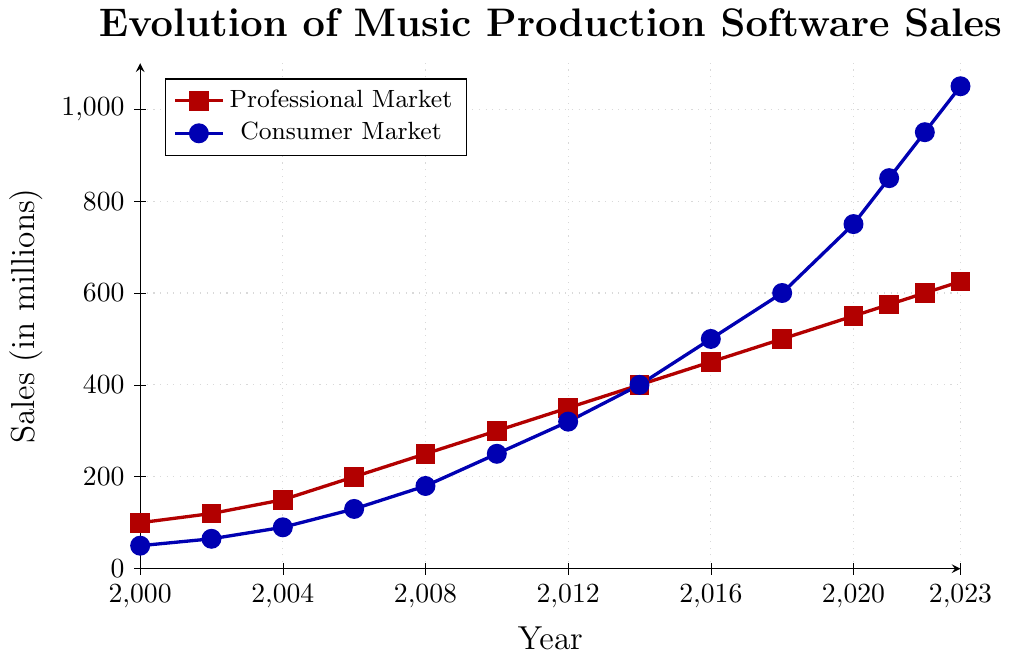Which market had higher sales in 2008? Check the values in 2008 on the chart, the Professional Market is at 250 million, while the Consumer Market is at 180 million.
Answer: Professional Market What was the difference in sales between the Consumer and Professional markets in 2023? Subtract the Professional Market value in 2023 (625 million) from the Consumer Market value in 2023 (1050 million): 1050 - 625.
Answer: 425 million Between 2010 and 2020, which market experienced the highest growth? Calculate the difference in sales for each market from 2010 to 2020: Professional Market (550 - 300 = 250 million), Consumer Market (750 - 250 = 500 million). The Consumer Market grew more.
Answer: Consumer Market What is the average annual increase in sales for the Professional Market from 2000 to 2006? Calculate the increase from 2000 to 2006 (200 - 100 = 100 million) and divide by the number of years (6 - 2000 = 6): 100 / 6.
Answer: Approximately 16.67 million per year In which year did the Consumer Market sales first surpass the Professional Market sales? Look for the year where the Consumer Market value exceeds the Professional Market value for the first time. This occurs in 2014, where Consumer Market sales are 400 million, and Professional Market sales are also 400 million. The Consumer Market hence surpassed in 2016.
Answer: 2016 